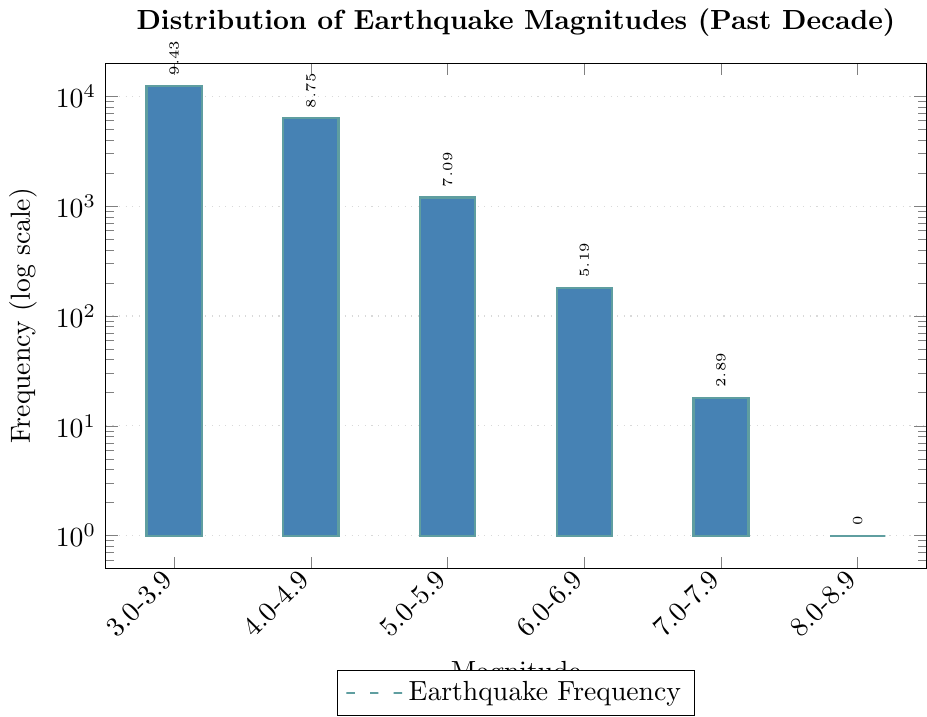What's the frequency of earthquakes in the 3.0-3.9 magnitude range? Referring to the bar representing the 3.0-3.9 magnitude range, we see that the associated frequency is clearly labeled.
Answer: 12500 Which magnitude range has the lowest frequency of earthquakes? Observing all bars, the 9.0+ magnitude range bar is the shortest and has a frequency of 0 labeled near it.
Answer: 9.0+ How much more frequent are earthquakes in the 4.0-4.9 range compared to the 6.0-6.9 range? Comparing the bars, the frequency for 4.0-4.9 is 6300 and for 6.0-6.9, it is 180. The difference is 6300 - 180.
Answer: 6120 Which two magnitude ranges have frequencies greater than 5000? Identifying the bars with a frequency greater than 5000, the 3.0-3.9 and 4.0-4.9 ranges meet this criterion with frequencies of 12500 and 6300 respectively.
Answer: 3.0-3.9, 4.0-4.9 What is the total frequency of earthquakes for magnitudes 5.0-5.9 and above? Adding the frequencies of all magnitude ranges from 5.0-5.9 and higher: 1200 (5.0-5.9) + 180 (6.0-6.9) + 18 (7.0-7.9) + 1 (8.0-8.9) + 0 (9.0+).
Answer: 1399 What is the ratio of the frequency of magnitude 3.0-3.9 earthquakes to magnitude 5.0-5.9 earthquakes? The frequency for 3.0-3.9 is 12500 and for 5.0-5.9, it is 1200. The ratio is 12500 / 1200.
Answer: 10.42 How do the frequencies of earthquakes in the 6.0-6.9 and 8.0-8.9 ranges compare visually? The bar for 6.0-6.9 is much taller than that for 8.0-8.9. The visual length difference represents a much higher frequency for 6.0-6.9.
Answer: 6.0-6.9 is much higher What percentage of earthquakes fall in the 3.0-3.9 range compared to the total number of earthquakes shown? Total earthquakes: 12500 (3.0-3.9) + 6300 (4.0-4.9) + 1200 (5.0-5.9) + 180 (6.0-6.9) + 18 (7.0-7.9) + 1 (8.0-8.9) + 0 (9.0+) = 20200. Percentage = (12500/20200) * 100%.
Answer: 61.88% What can be inferred about the occurrence of high magnitude earthquakes based on the figure? Higher magnitude earthquakes (7.0+) have significantly lower frequencies, with the 8.0-8.9 range only having 1 event and none in the 9.0+ range, indicating their rarity.
Answer: They are rare Among the earthquake magnitudes 4.0-4.9 and 5.0-5.9, which one has a higher frequency, and by how much? The bar for 4.0-4.9 is higher with a frequency of 6300 compared to 1200 for 5.0-5.9. The difference is 6300 - 1200.
Answer: 4.0-4.9 is higher by 5100 